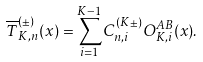Convert formula to latex. <formula><loc_0><loc_0><loc_500><loc_500>\overline { T } ^ { ( \pm ) } _ { K , n } ( x ) = \sum _ { i = 1 } ^ { K - 1 } C ^ { ( K \pm ) } _ { n , i } O ^ { A B } _ { K , i } ( x ) .</formula> 